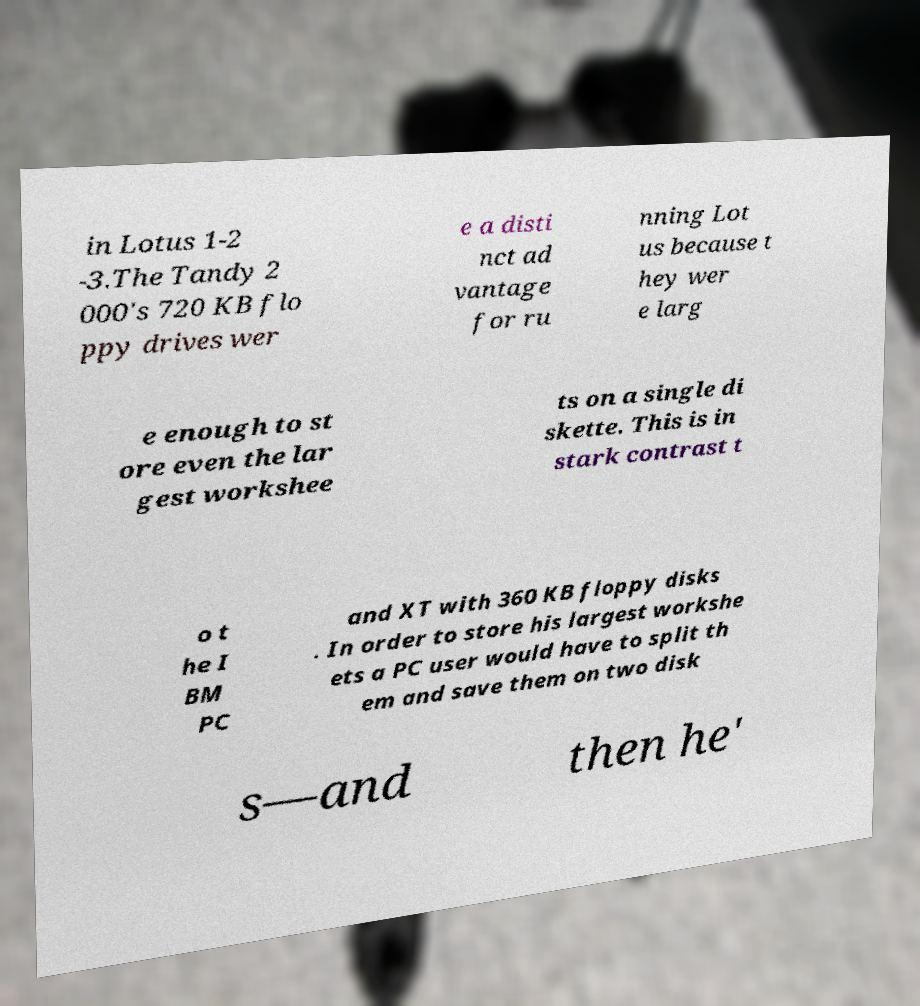For documentation purposes, I need the text within this image transcribed. Could you provide that? in Lotus 1-2 -3.The Tandy 2 000's 720 KB flo ppy drives wer e a disti nct ad vantage for ru nning Lot us because t hey wer e larg e enough to st ore even the lar gest workshee ts on a single di skette. This is in stark contrast t o t he I BM PC and XT with 360 KB floppy disks . In order to store his largest workshe ets a PC user would have to split th em and save them on two disk s—and then he' 